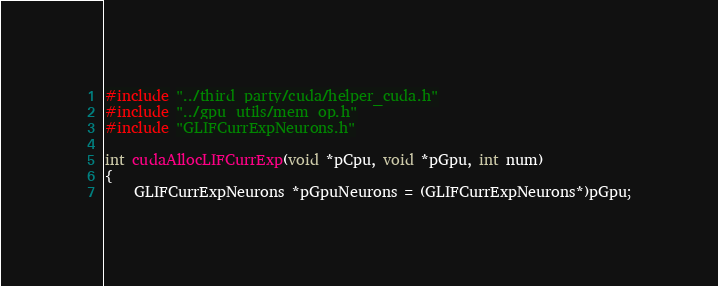Convert code to text. <code><loc_0><loc_0><loc_500><loc_500><_Cuda_>
#include "../third_party/cuda/helper_cuda.h"
#include "../gpu_utils/mem_op.h"
#include "GLIFCurrExpNeurons.h"

int cudaAllocLIFCurrExp(void *pCpu, void *pGpu, int num)
{
	GLIFCurrExpNeurons *pGpuNeurons = (GLIFCurrExpNeurons*)pGpu;</code> 